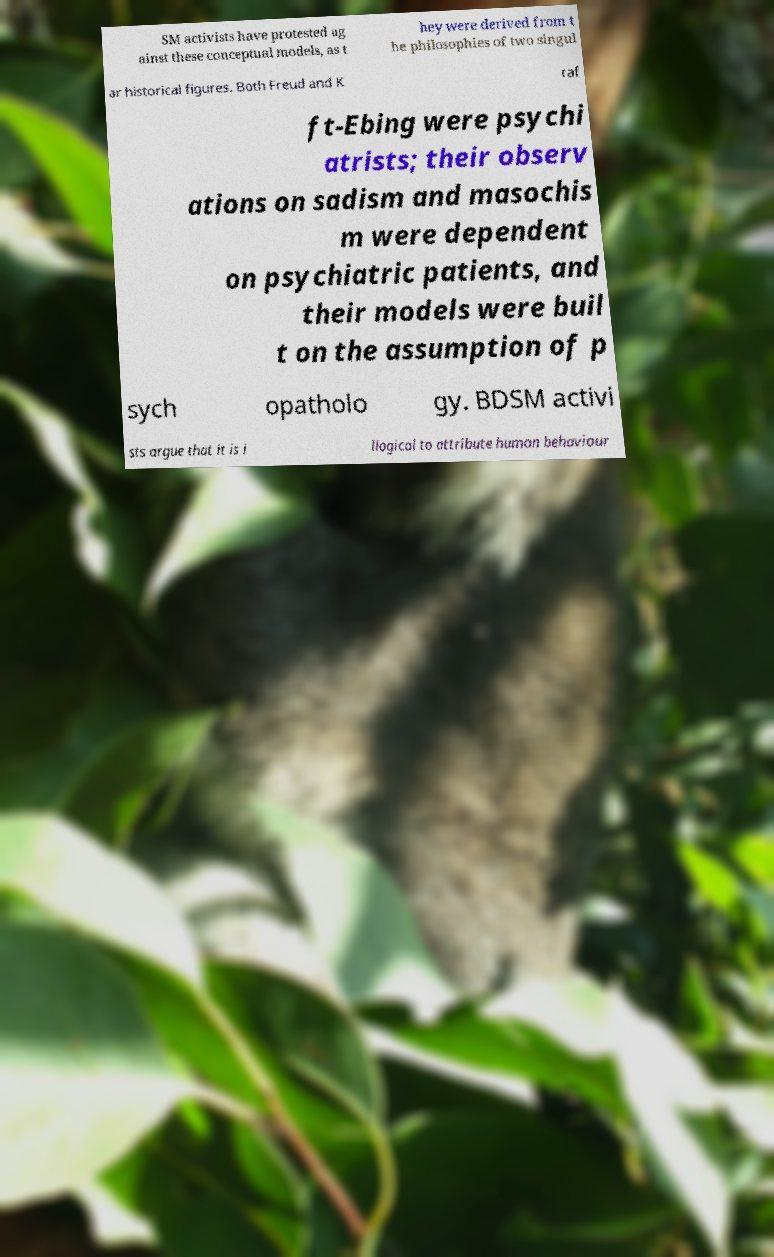I need the written content from this picture converted into text. Can you do that? SM activists have protested ag ainst these conceptual models, as t hey were derived from t he philosophies of two singul ar historical figures. Both Freud and K raf ft-Ebing were psychi atrists; their observ ations on sadism and masochis m were dependent on psychiatric patients, and their models were buil t on the assumption of p sych opatholo gy. BDSM activi sts argue that it is i llogical to attribute human behaviour 